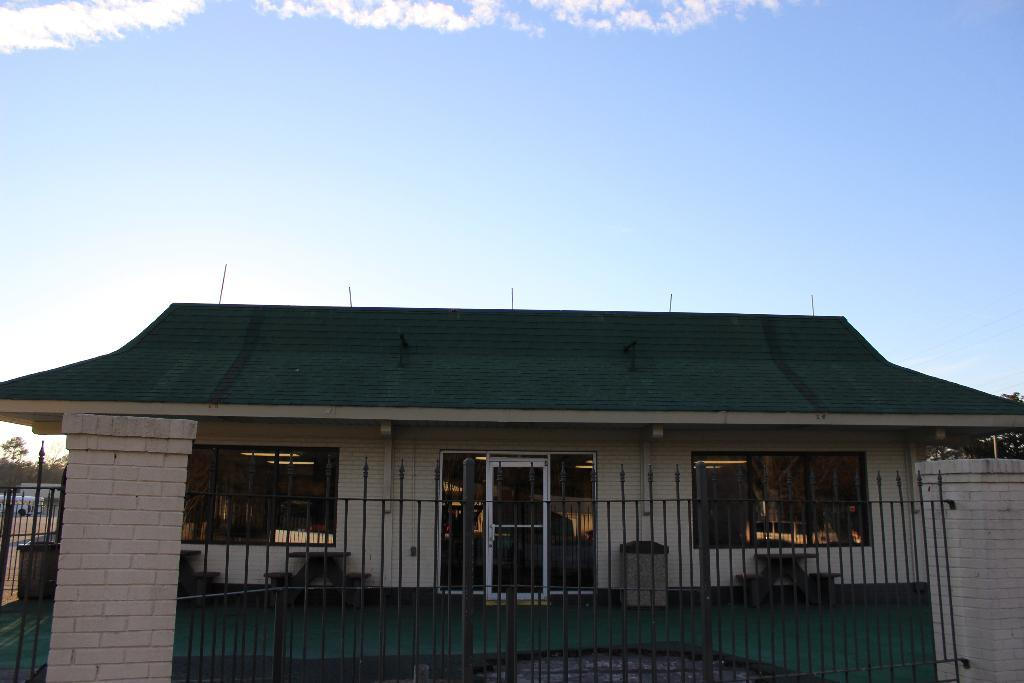What type of structure can be seen in the image? There is a house with glass doors and windows in the image. What are some other features present in the image? There is a fence, pillars, trees, and a blue sky with clouds in the background. Can you see a mountain in the background of the image? No, there is no mountain visible in the image. Are there any dolls or donkeys present in the image? No, there are no dolls or donkeys present in the image. 